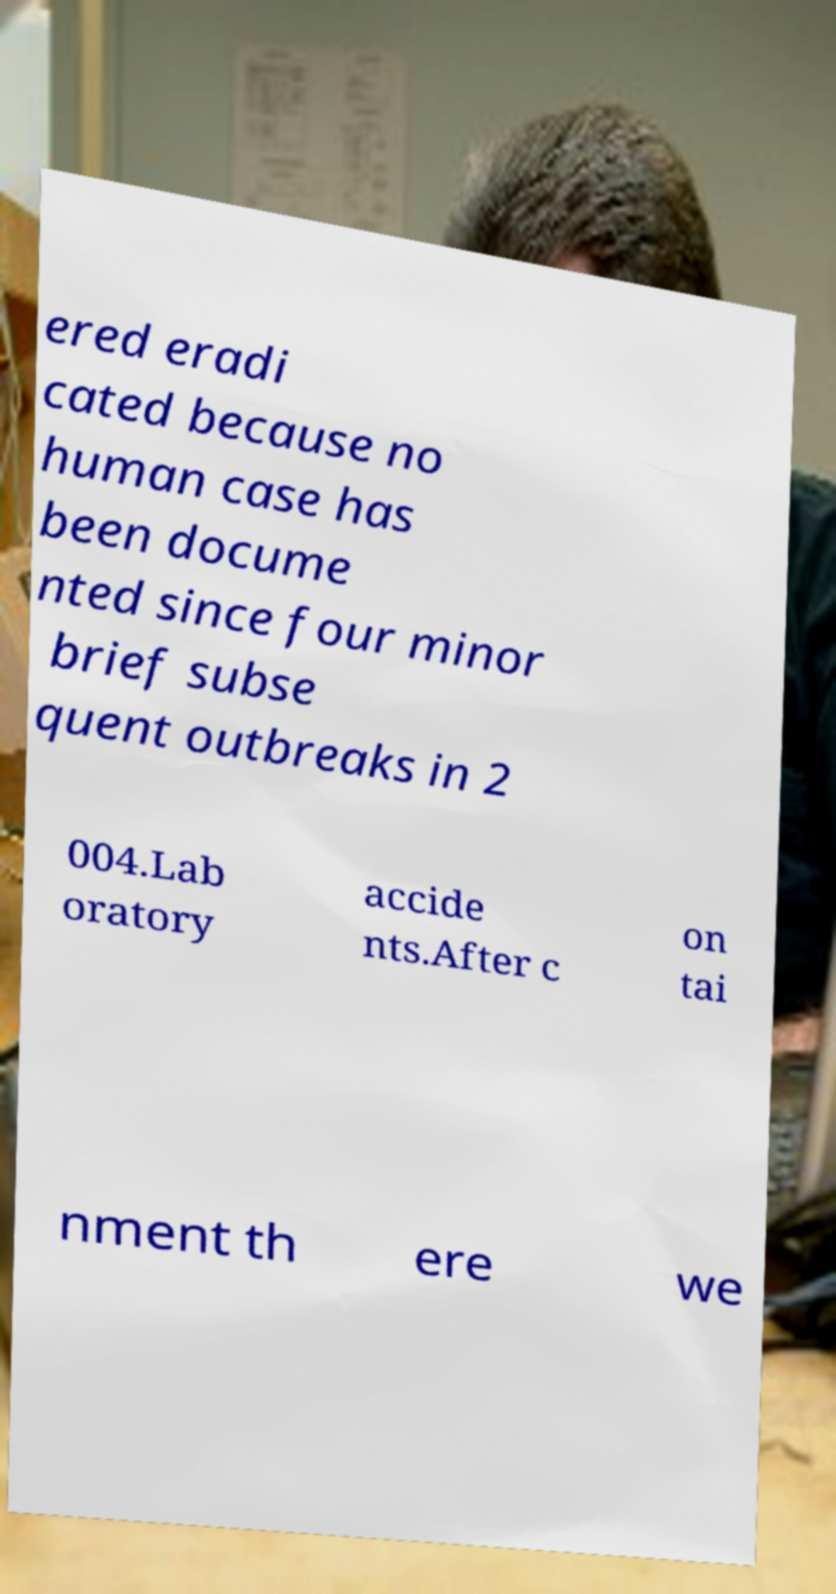I need the written content from this picture converted into text. Can you do that? ered eradi cated because no human case has been docume nted since four minor brief subse quent outbreaks in 2 004.Lab oratory accide nts.After c on tai nment th ere we 